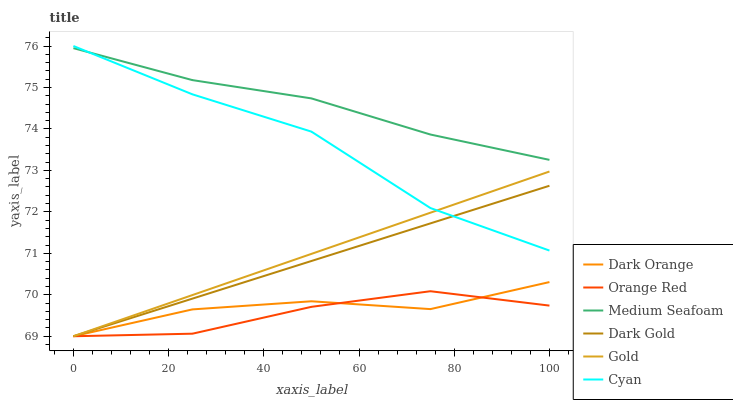Does Orange Red have the minimum area under the curve?
Answer yes or no. Yes. Does Medium Seafoam have the maximum area under the curve?
Answer yes or no. Yes. Does Gold have the minimum area under the curve?
Answer yes or no. No. Does Gold have the maximum area under the curve?
Answer yes or no. No. Is Gold the smoothest?
Answer yes or no. Yes. Is Cyan the roughest?
Answer yes or no. Yes. Is Dark Gold the smoothest?
Answer yes or no. No. Is Dark Gold the roughest?
Answer yes or no. No. Does Medium Seafoam have the lowest value?
Answer yes or no. No. Does Cyan have the highest value?
Answer yes or no. Yes. Does Gold have the highest value?
Answer yes or no. No. Is Dark Orange less than Cyan?
Answer yes or no. Yes. Is Medium Seafoam greater than Orange Red?
Answer yes or no. Yes. Does Dark Orange intersect Cyan?
Answer yes or no. No. 